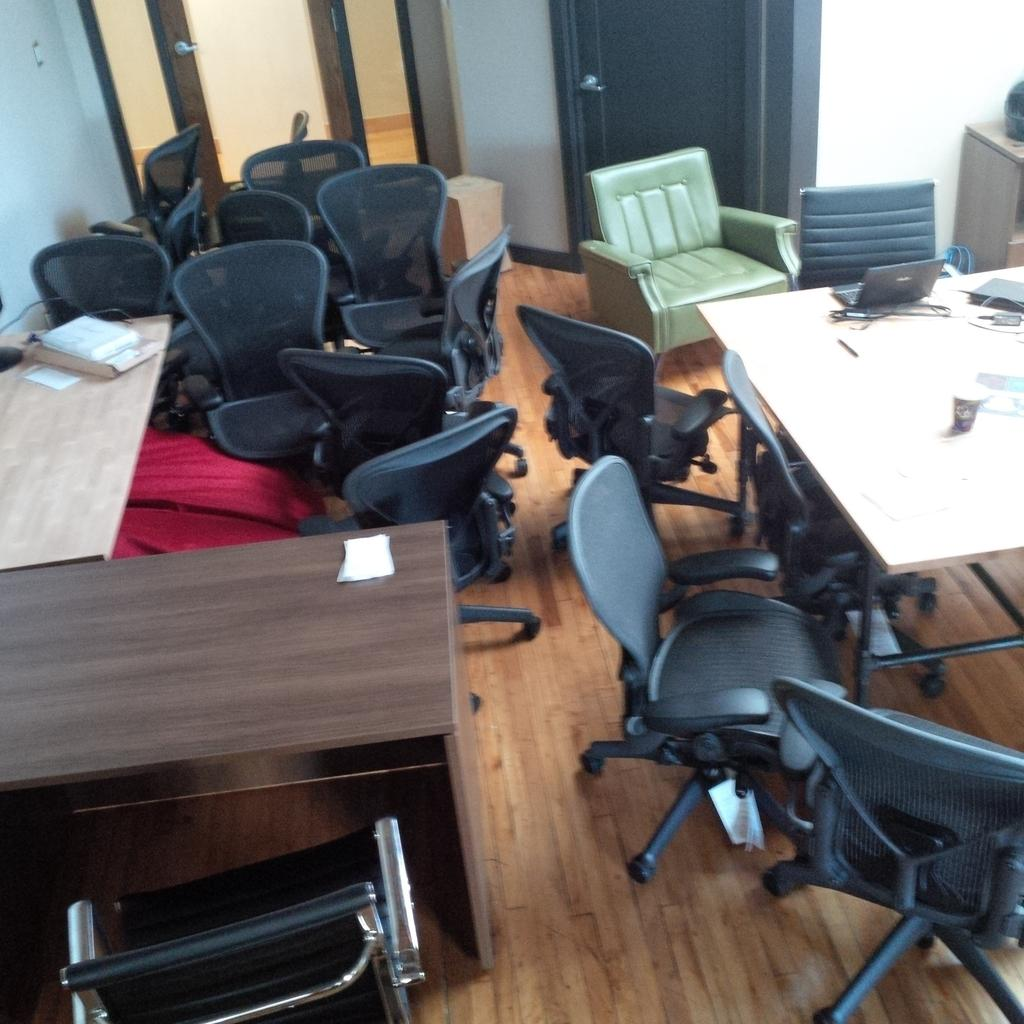Where is the image taken? The image is taken in a room. What furniture can be seen in the room? The room contains chairs and tables. What type of seating is located in the top right of the image? There is a sofa in the top right of the image. What color is the sofa? The sofa is green in color. What is visible behind the sofa? There are doors visible behind the sofa. What type of toothbrush is visible on the sofa in the image? There is no toothbrush present on the sofa in the image. What substance is being used to create ice sculptures in the image? There is no ice sculpture or substance being used to create one in the image. 